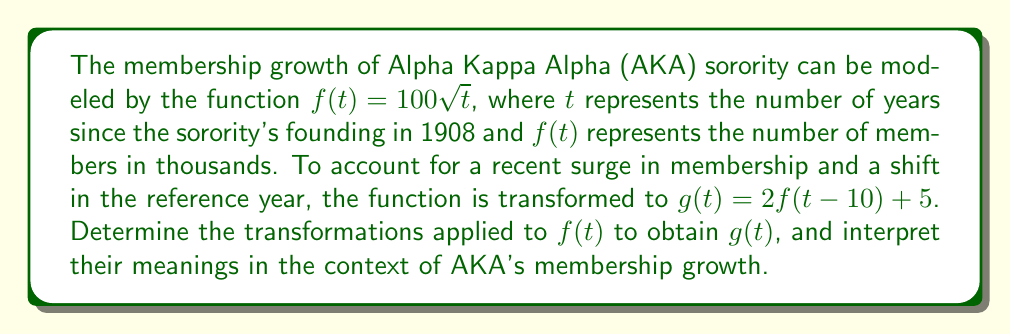Can you answer this question? Let's analyze the transformation step-by-step:

1) The original function is $f(t) = 100\sqrt{t}$

2) The new function is $g(t) = 2f(t-10) + 5$

3) To identify the transformations, let's break down $g(t)$:

   a) Inside the function: $(t-10)$
      This represents a horizontal shift 10 units to the right.
      Meaning: The new function considers time relative to 1918 (10 years after AKA's founding) instead of 1908.

   b) Outside the function: $2f(\ldots)$
      This represents a vertical stretch by a factor of 2.
      Meaning: The membership growth rate has doubled compared to the original model.

   c) Addition at the end: $\ldots + 5$
      This represents a vertical shift 5 units upward.
      Meaning: There's a base increase of 5,000 members added to the transformed function.

4) The order of transformations:
   - First, shift horizontally right by 10 units
   - Then, stretch vertically by a factor of 2
   - Finally, shift vertically up by 5 units

5) In function notation:
   $g(t) = 2f(t-10) + 5$
   $= 2(100\sqrt{t-10}) + 5$
   $= 200\sqrt{t-10} + 5$

This transformed function represents AKA's accelerated membership growth, starting from a later reference point and with an additional base membership.
Answer: Horizontal shift right 10 units, vertical stretch by factor 2, vertical shift up 5 units 